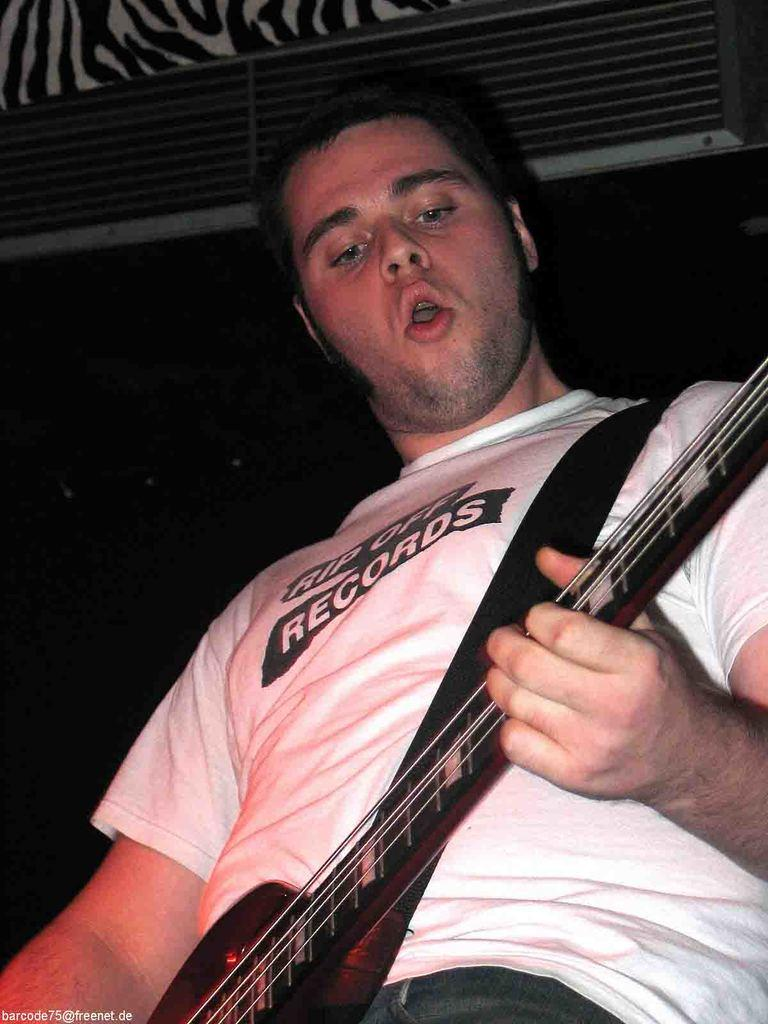What is the man in the image doing? The man is singing a song and playing a guitar. What instrument is the man playing in the image? The man is playing a guitar. What type of doll is the man wearing on his skirt in the image? There is no doll or skirt present in the image; the man is simply playing a guitar and singing a song. 